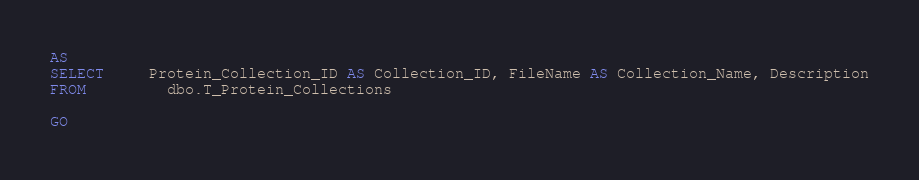Convert code to text. <code><loc_0><loc_0><loc_500><loc_500><_SQL_>AS
SELECT     Protein_Collection_ID AS Collection_ID, FileName AS Collection_Name, Description
FROM         dbo.T_Protein_Collections

GO
</code> 